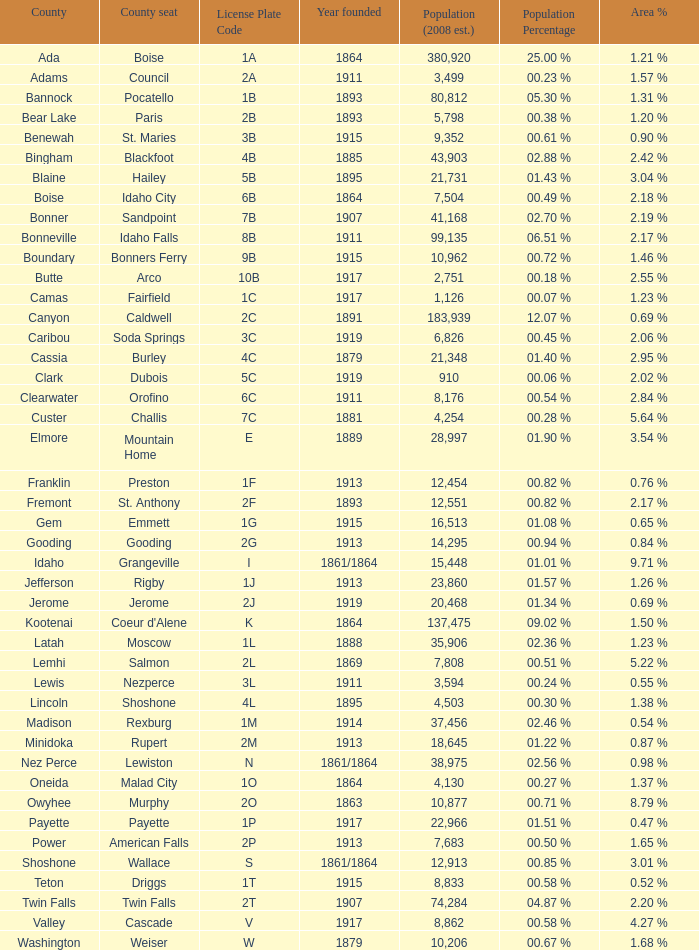What is the license plate code for the country with an area of 784? 3B. Can you give me this table as a dict? {'header': ['County', 'County seat', 'License Plate Code', 'Year founded', 'Population (2008 est.)', 'Population Percentage', 'Area %'], 'rows': [['Ada', 'Boise', '1A', '1864', '380,920', '25.00 %', '1.21 %'], ['Adams', 'Council', '2A', '1911', '3,499', '00.23 %', '1.57 %'], ['Bannock', 'Pocatello', '1B', '1893', '80,812', '05.30 %', '1.31 %'], ['Bear Lake', 'Paris', '2B', '1893', '5,798', '00.38 %', '1.20 %'], ['Benewah', 'St. Maries', '3B', '1915', '9,352', '00.61 %', '0.90 %'], ['Bingham', 'Blackfoot', '4B', '1885', '43,903', '02.88 %', '2.42 %'], ['Blaine', 'Hailey', '5B', '1895', '21,731', '01.43 %', '3.04 %'], ['Boise', 'Idaho City', '6B', '1864', '7,504', '00.49 %', '2.18 %'], ['Bonner', 'Sandpoint', '7B', '1907', '41,168', '02.70 %', '2.19 %'], ['Bonneville', 'Idaho Falls', '8B', '1911', '99,135', '06.51 %', '2.17 %'], ['Boundary', 'Bonners Ferry', '9B', '1915', '10,962', '00.72 %', '1.46 %'], ['Butte', 'Arco', '10B', '1917', '2,751', '00.18 %', '2.55 %'], ['Camas', 'Fairfield', '1C', '1917', '1,126', '00.07 %', '1.23 %'], ['Canyon', 'Caldwell', '2C', '1891', '183,939', '12.07 %', '0.69 %'], ['Caribou', 'Soda Springs', '3C', '1919', '6,826', '00.45 %', '2.06 %'], ['Cassia', 'Burley', '4C', '1879', '21,348', '01.40 %', '2.95 %'], ['Clark', 'Dubois', '5C', '1919', '910', '00.06 %', '2.02 %'], ['Clearwater', 'Orofino', '6C', '1911', '8,176', '00.54 %', '2.84 %'], ['Custer', 'Challis', '7C', '1881', '4,254', '00.28 %', '5.64 %'], ['Elmore', 'Mountain Home', 'E', '1889', '28,997', '01.90 %', '3.54 %'], ['Franklin', 'Preston', '1F', '1913', '12,454', '00.82 %', '0.76 %'], ['Fremont', 'St. Anthony', '2F', '1893', '12,551', '00.82 %', '2.17 %'], ['Gem', 'Emmett', '1G', '1915', '16,513', '01.08 %', '0.65 %'], ['Gooding', 'Gooding', '2G', '1913', '14,295', '00.94 %', '0.84 %'], ['Idaho', 'Grangeville', 'I', '1861/1864', '15,448', '01.01 %', '9.71 %'], ['Jefferson', 'Rigby', '1J', '1913', '23,860', '01.57 %', '1.26 %'], ['Jerome', 'Jerome', '2J', '1919', '20,468', '01.34 %', '0.69 %'], ['Kootenai', "Coeur d'Alene", 'K', '1864', '137,475', '09.02 %', '1.50 %'], ['Latah', 'Moscow', '1L', '1888', '35,906', '02.36 %', '1.23 %'], ['Lemhi', 'Salmon', '2L', '1869', '7,808', '00.51 %', '5.22 %'], ['Lewis', 'Nezperce', '3L', '1911', '3,594', '00.24 %', '0.55 %'], ['Lincoln', 'Shoshone', '4L', '1895', '4,503', '00.30 %', '1.38 %'], ['Madison', 'Rexburg', '1M', '1914', '37,456', '02.46 %', '0.54 %'], ['Minidoka', 'Rupert', '2M', '1913', '18,645', '01.22 %', '0.87 %'], ['Nez Perce', 'Lewiston', 'N', '1861/1864', '38,975', '02.56 %', '0.98 %'], ['Oneida', 'Malad City', '1O', '1864', '4,130', '00.27 %', '1.37 %'], ['Owyhee', 'Murphy', '2O', '1863', '10,877', '00.71 %', '8.79 %'], ['Payette', 'Payette', '1P', '1917', '22,966', '01.51 %', '0.47 %'], ['Power', 'American Falls', '2P', '1913', '7,683', '00.50 %', '1.65 %'], ['Shoshone', 'Wallace', 'S', '1861/1864', '12,913', '00.85 %', '3.01 %'], ['Teton', 'Driggs', '1T', '1915', '8,833', '00.58 %', '0.52 %'], ['Twin Falls', 'Twin Falls', '2T', '1907', '74,284', '04.87 %', '2.20 %'], ['Valley', 'Cascade', 'V', '1917', '8,862', '00.58 %', '4.27 %'], ['Washington', 'Weiser', 'W', '1879', '10,206', '00.67 %', '1.68 %']]} 